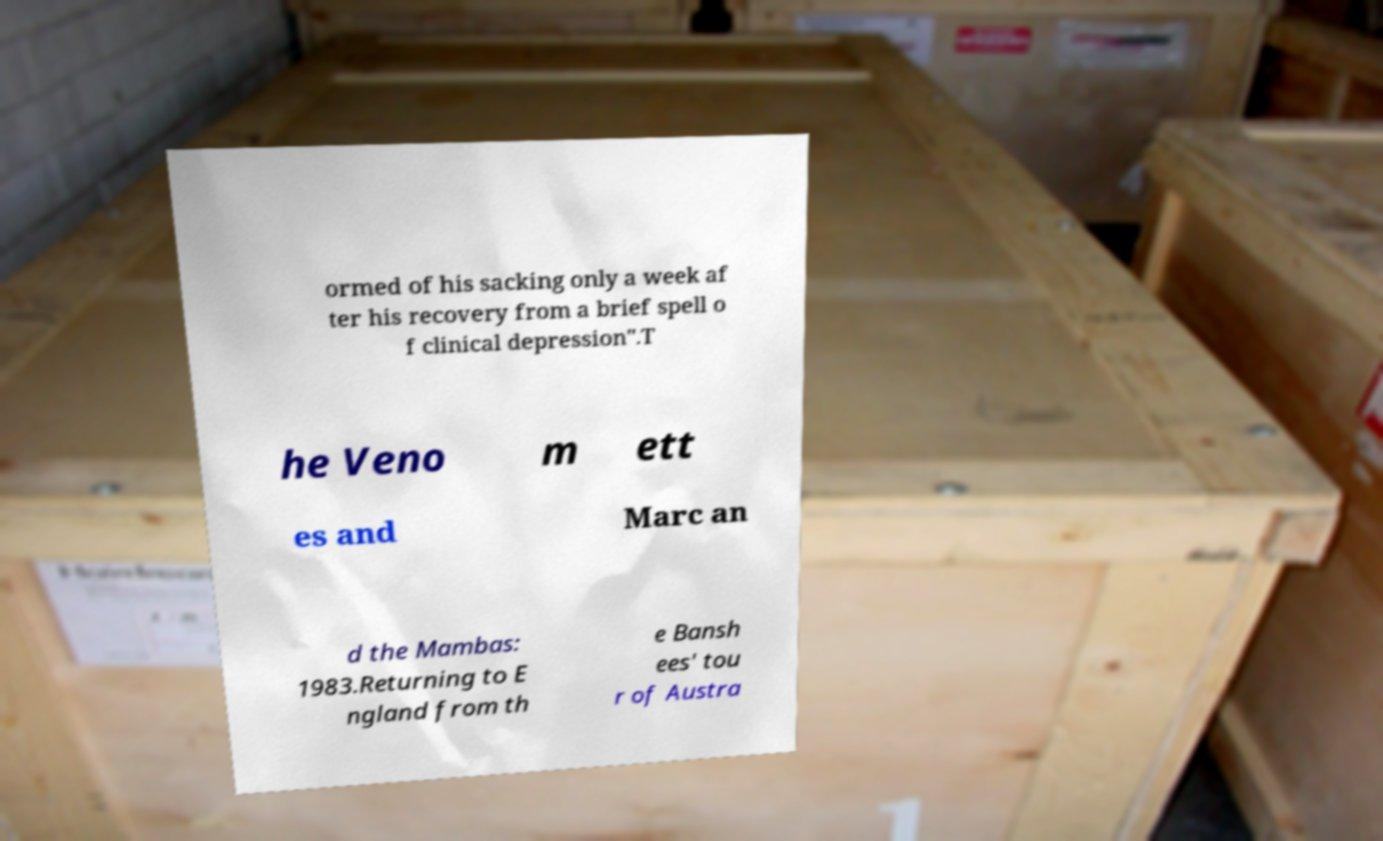There's text embedded in this image that I need extracted. Can you transcribe it verbatim? ormed of his sacking only a week af ter his recovery from a brief spell o f clinical depression".T he Veno m ett es and Marc an d the Mambas: 1983.Returning to E ngland from th e Bansh ees' tou r of Austra 